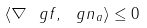Convert formula to latex. <formula><loc_0><loc_0><loc_500><loc_500>\langle \nabla \ g f , \ g n _ { a } \rangle \leq 0</formula> 